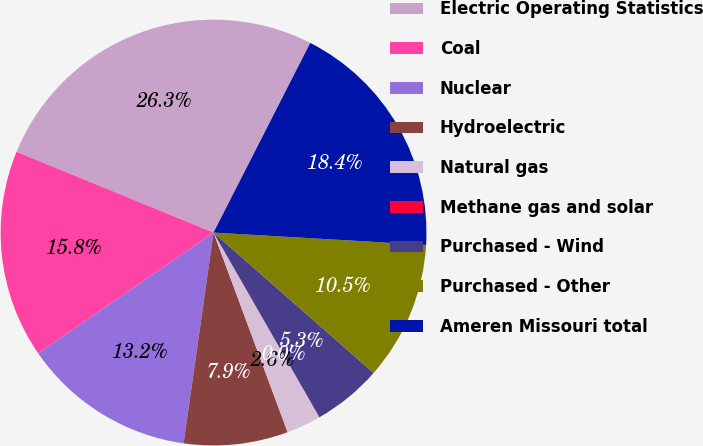<chart> <loc_0><loc_0><loc_500><loc_500><pie_chart><fcel>Electric Operating Statistics<fcel>Coal<fcel>Nuclear<fcel>Hydroelectric<fcel>Natural gas<fcel>Methane gas and solar<fcel>Purchased - Wind<fcel>Purchased - Other<fcel>Ameren Missouri total<nl><fcel>26.31%<fcel>15.79%<fcel>13.16%<fcel>7.9%<fcel>2.63%<fcel>0.0%<fcel>5.26%<fcel>10.53%<fcel>18.42%<nl></chart> 